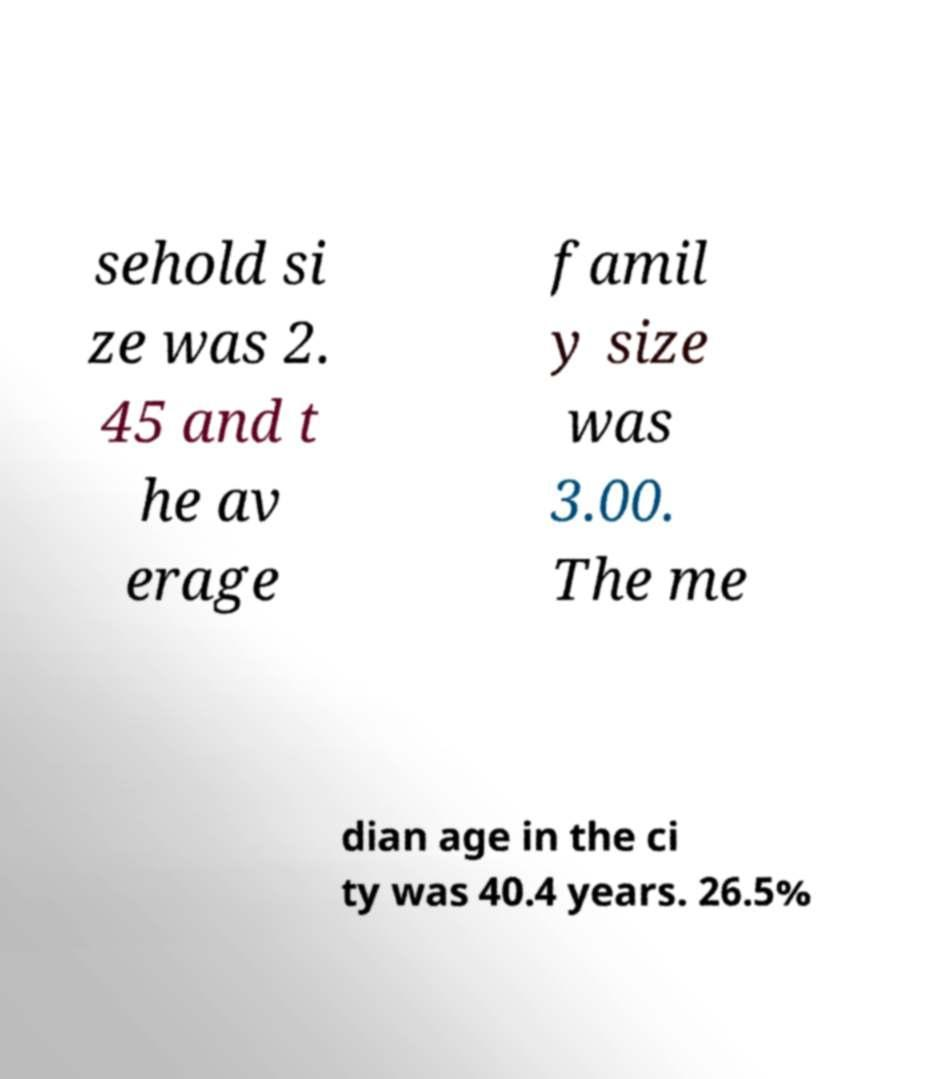Can you read and provide the text displayed in the image?This photo seems to have some interesting text. Can you extract and type it out for me? sehold si ze was 2. 45 and t he av erage famil y size was 3.00. The me dian age in the ci ty was 40.4 years. 26.5% 